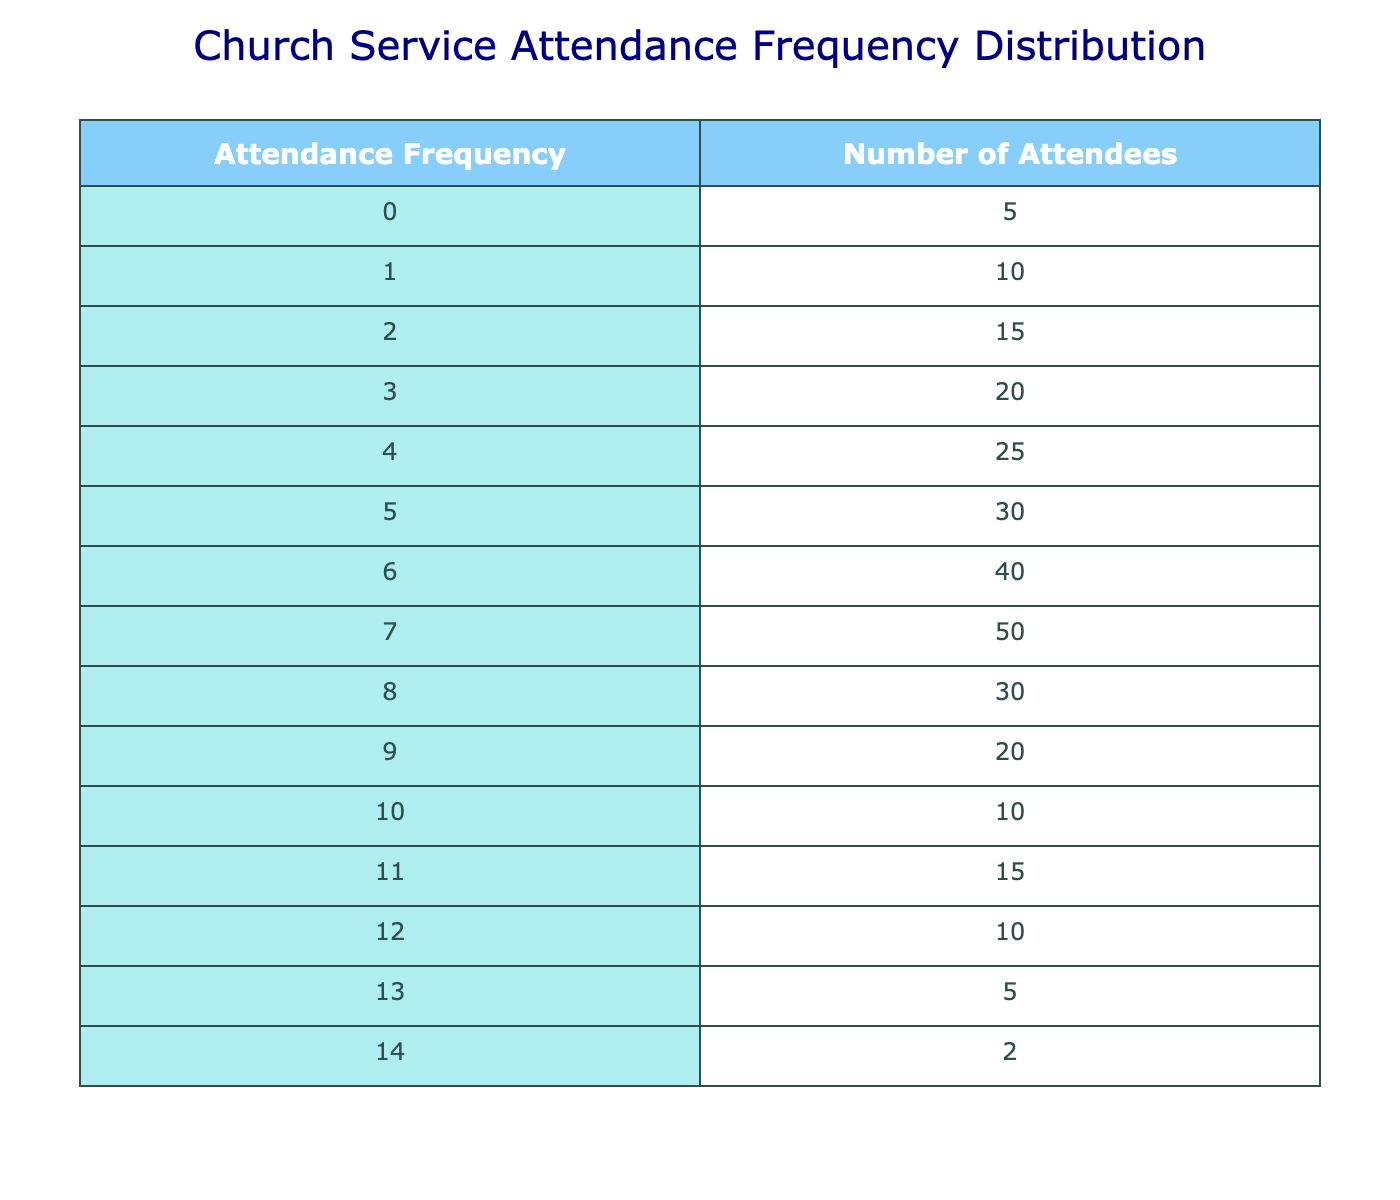What is the highest number of attendees recorded? The highest number of attendees is found in the row with the highest attendance frequency. Looking at the table, the maximum attendance frequency is 7, which corresponds to 50 attendees.
Answer: 50 How many attendees attended church services 0 times? The number of attendees who attended church services 0 times is directly provided in the table under the attendance frequency of 0. This value is 5.
Answer: 5 What is the total number of attendees who attended church services 5 times or more? To find the total number of attendees for 5 times or more, we need to sum the values for attendance frequencies 5, 6, 7, 8, 9, 10, 11, 12, 13, and 14. The total is 30 + 40 + 50 + 30 + 20 + 10 + 15 + 10 + 5 + 2 = 252.
Answer: 252 Is there more than one attendee who attended church services 14 times? Referring to the table, the number of attendees who attended 14 times is given as 2, which is indeed more than one.
Answer: Yes What is the average attendance frequency across all attendees? First, we need to calculate the total number of attendees and the total attendance frequency. For total attendees: (5 * 0) + (10 * 1) + (15 * 2) + (20 * 3) + (25 * 4) + (30 * 5) + (40 * 6) + (50 * 7) + (30 * 8) + (20 * 9) + (10 * 10) + (15 * 11) + (10 * 12) + (5 * 13) + (2 * 14) = 340. The total number of occurrences can be obtained by adding all the attendees: 5 + 10 + 15 + 20 + 25 + 30 + 40 + 50 + 30 + 20 + 10 + 15 + 10 + 5 + 2 = 340. The average is then 340/15 = 22.67.
Answer: Approximately 22.67 What is the difference in attendance between those who attended 8 times and those who attended 4 times? The number of attendees who attended 8 times is 30 and those who attended 4 times is 25. The difference is calculated as 30 - 25, which equals 5.
Answer: 5 